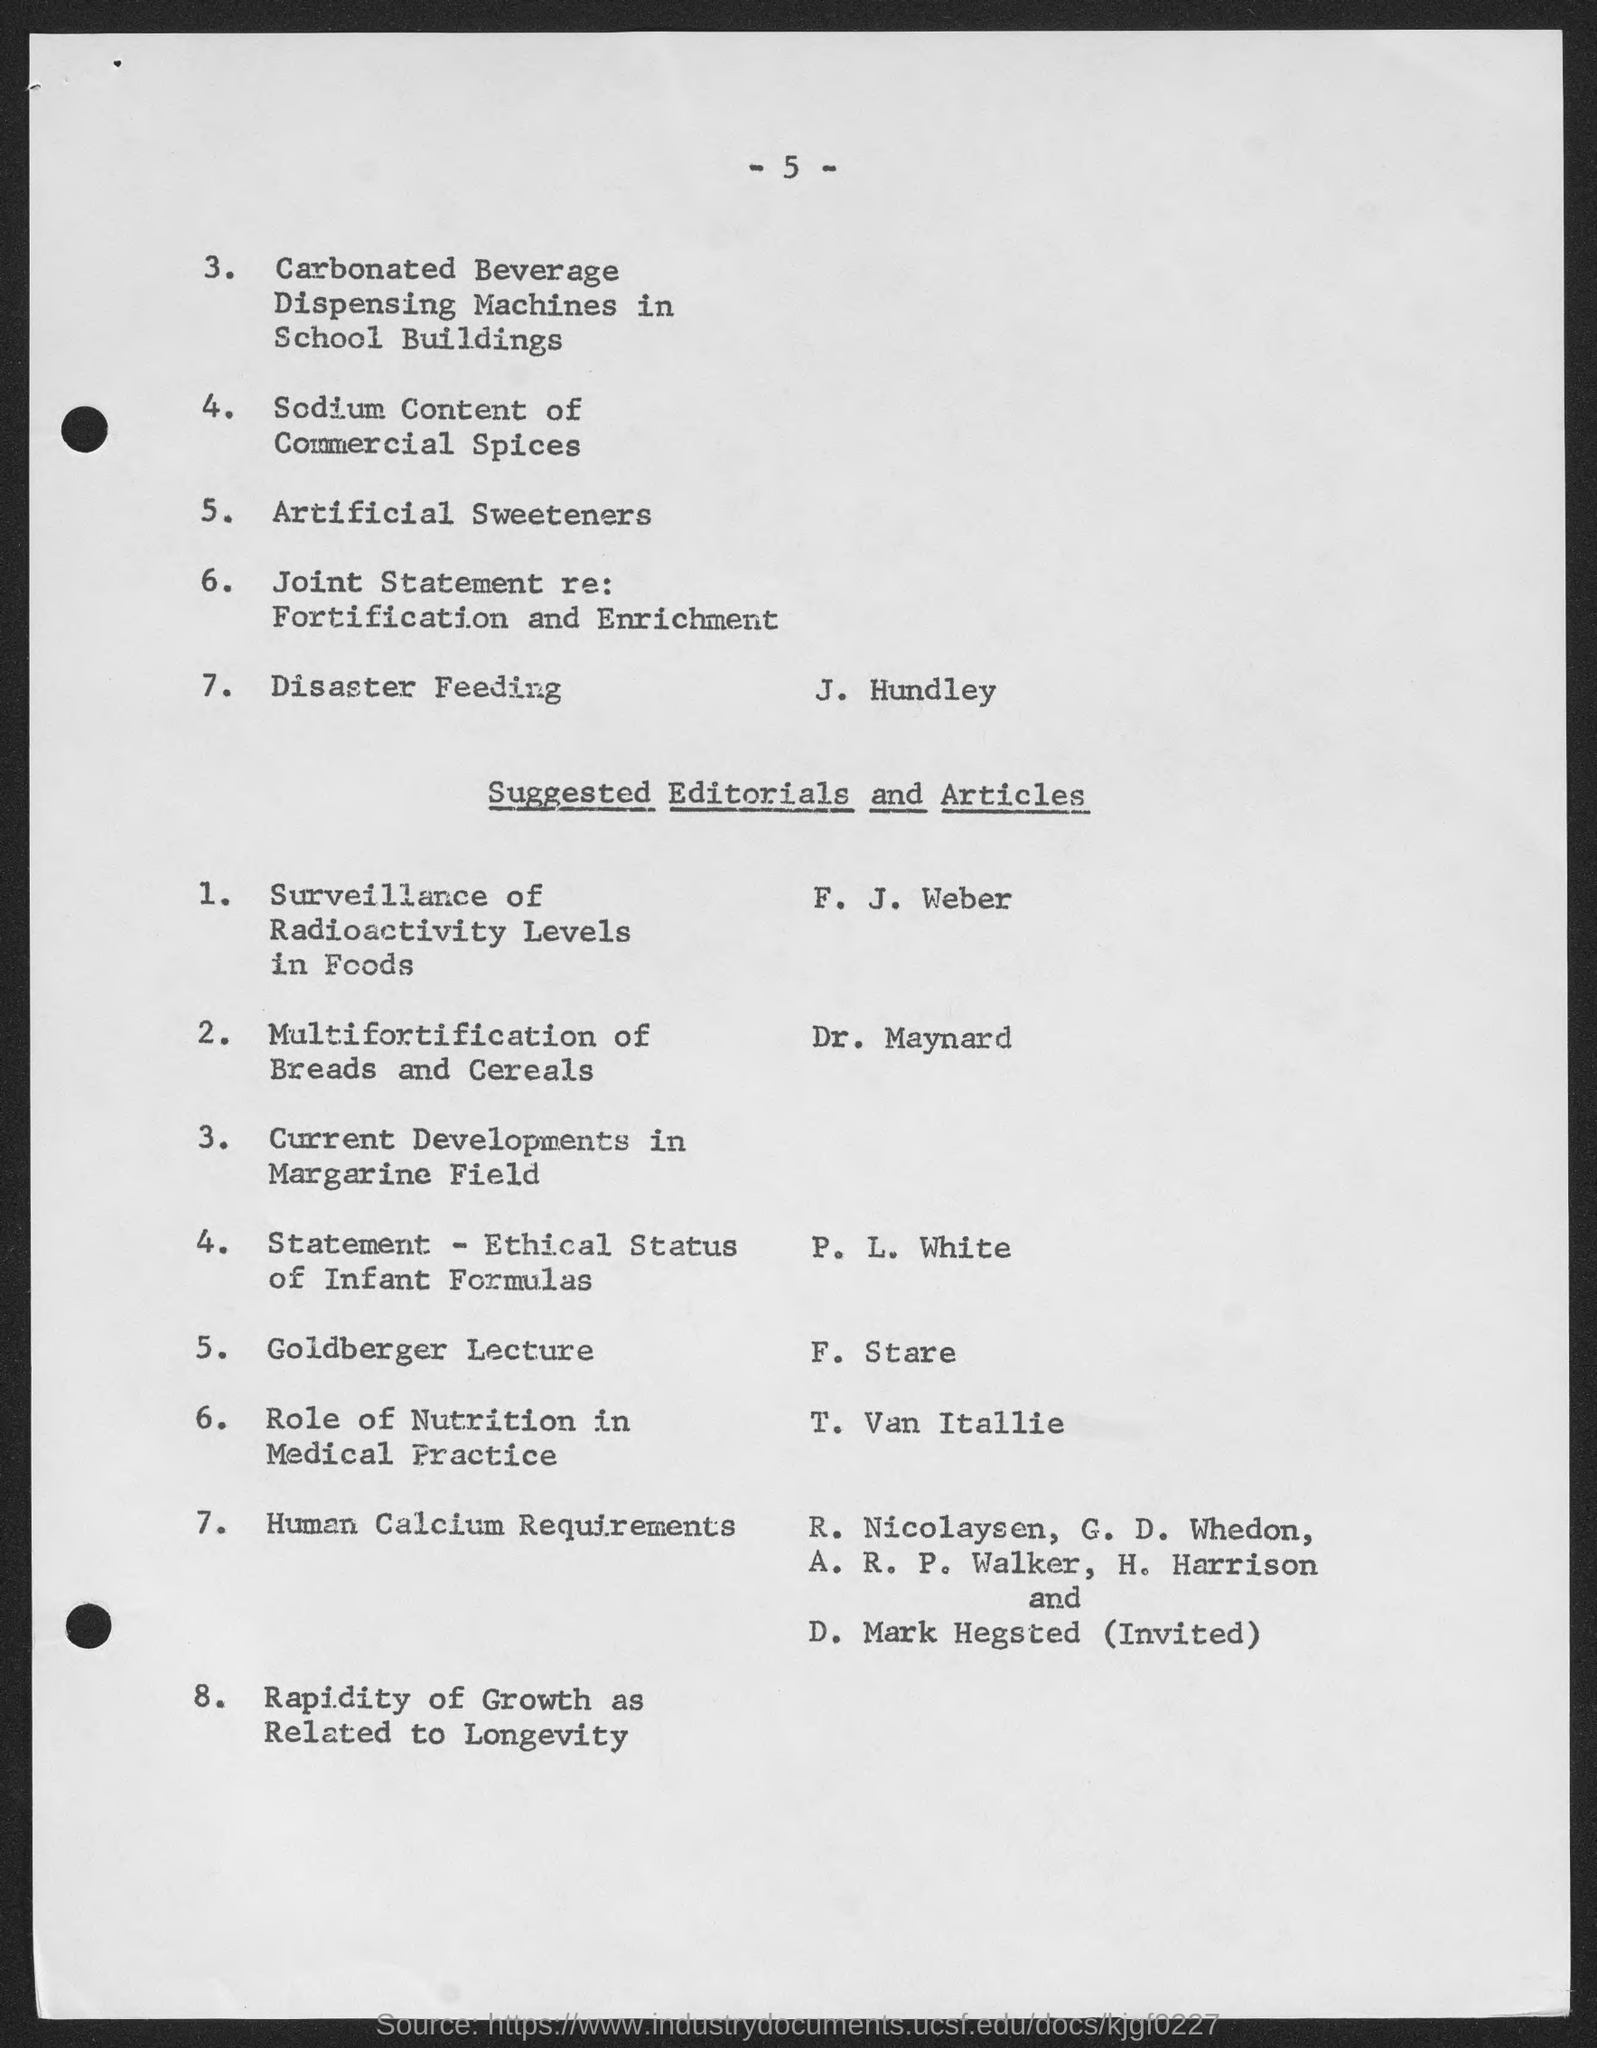What is the number at top of the page ?
Ensure brevity in your answer.  -5-. 